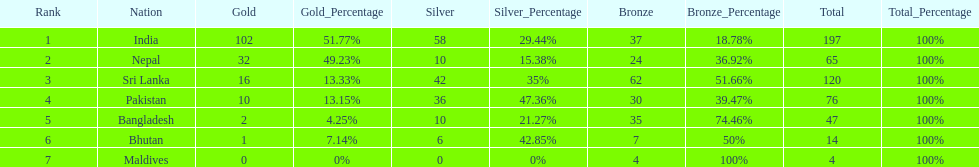Who has won the most bronze medals? Sri Lanka. 